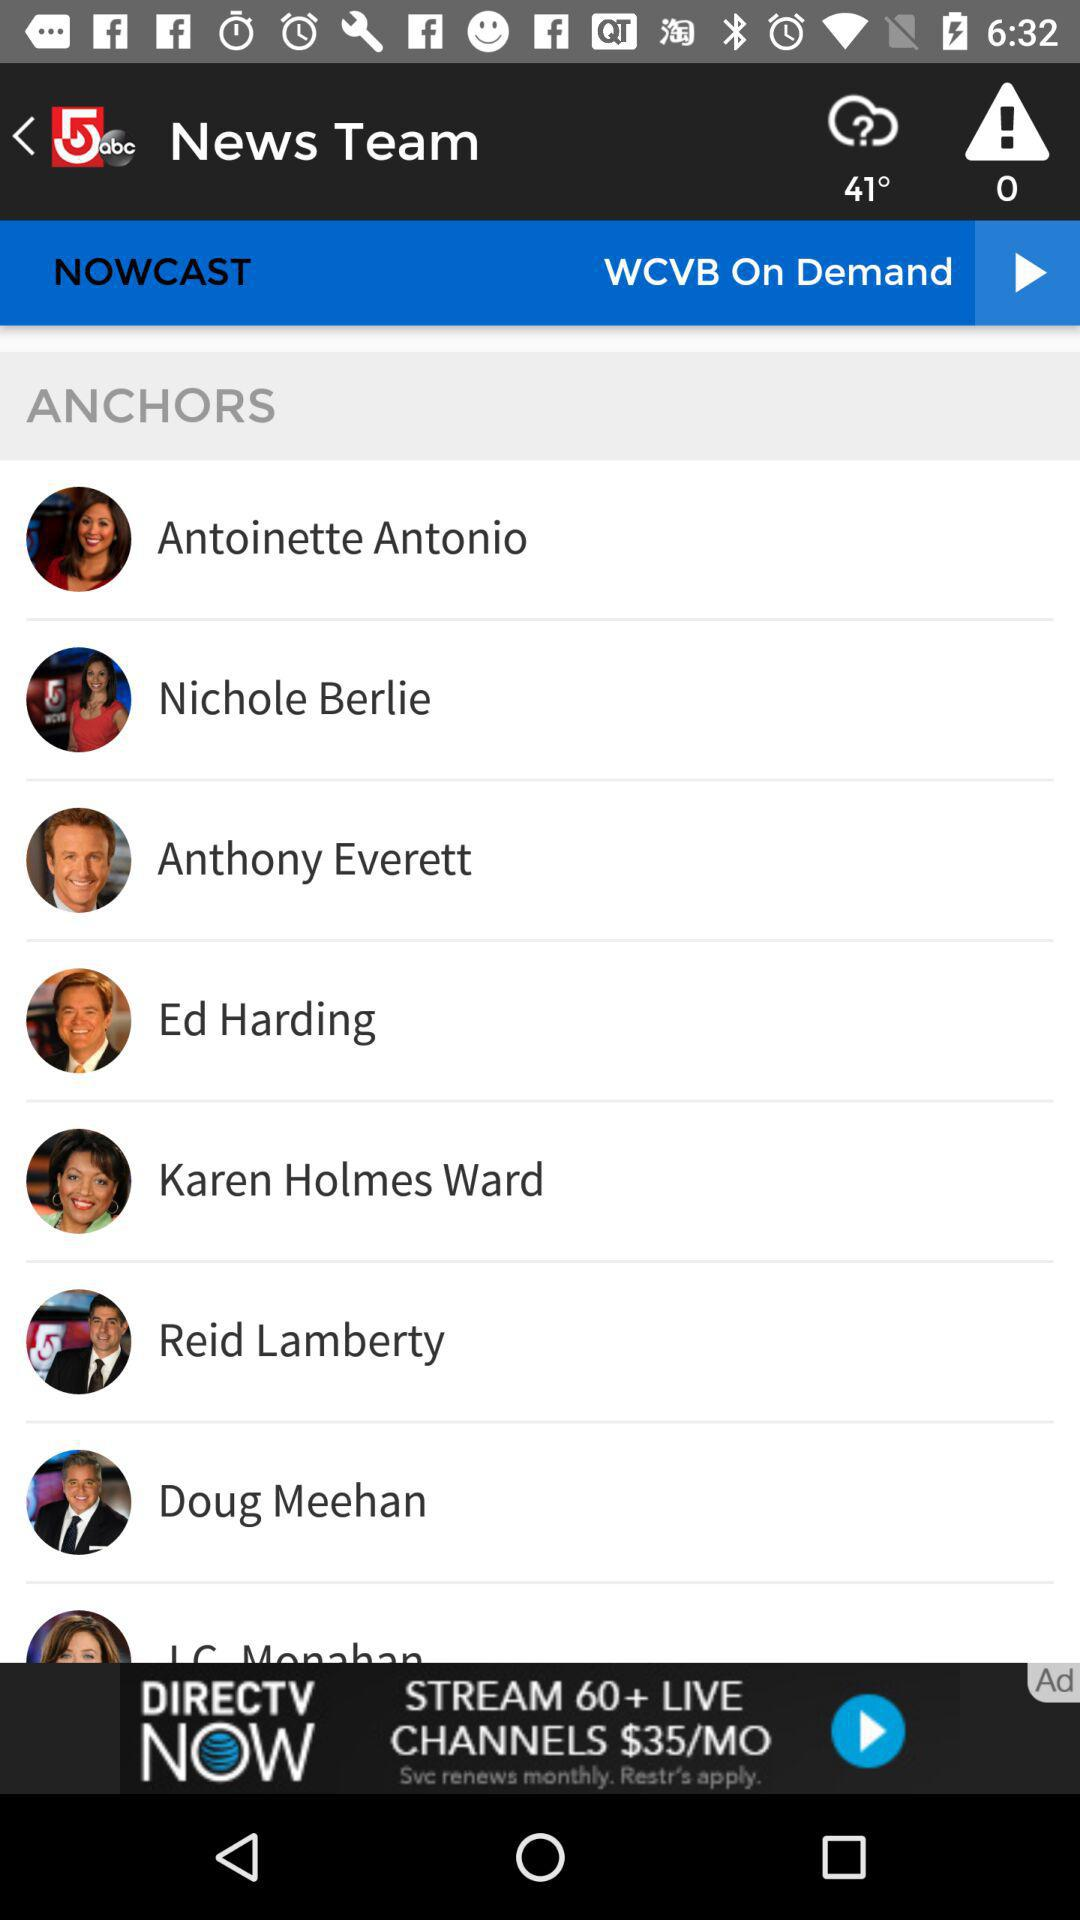How many of the anchors are women?
Answer the question using a single word or phrase. 4 